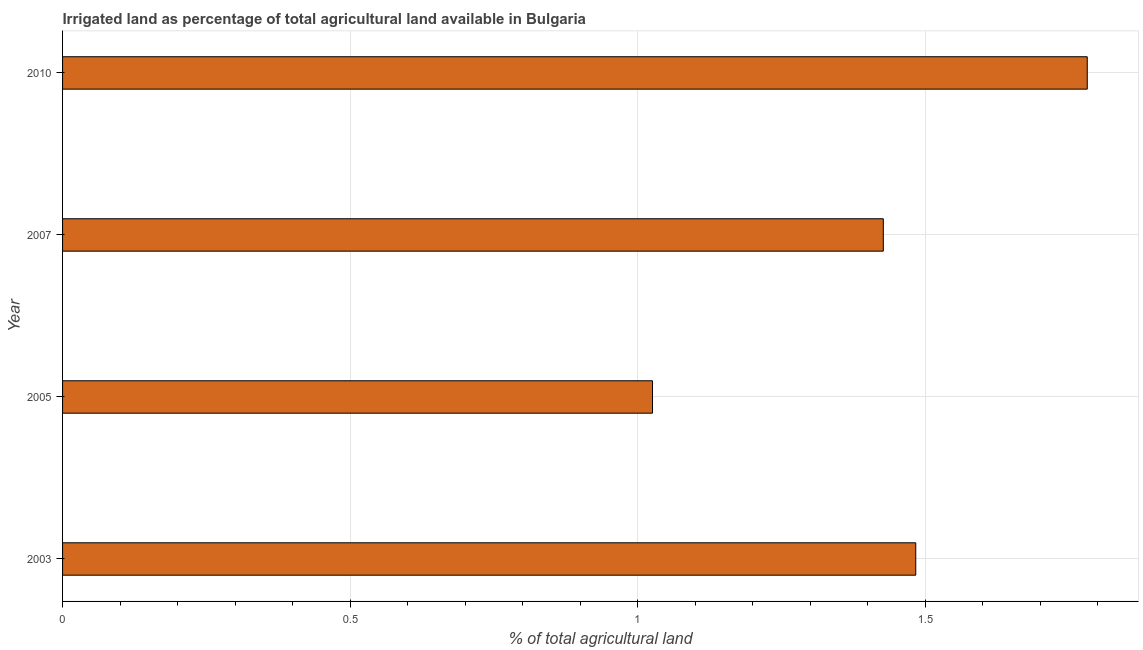Does the graph contain grids?
Your response must be concise. Yes. What is the title of the graph?
Provide a short and direct response. Irrigated land as percentage of total agricultural land available in Bulgaria. What is the label or title of the X-axis?
Offer a very short reply. % of total agricultural land. What is the label or title of the Y-axis?
Ensure brevity in your answer.  Year. What is the percentage of agricultural irrigated land in 2007?
Offer a very short reply. 1.43. Across all years, what is the maximum percentage of agricultural irrigated land?
Ensure brevity in your answer.  1.78. Across all years, what is the minimum percentage of agricultural irrigated land?
Provide a short and direct response. 1.03. In which year was the percentage of agricultural irrigated land maximum?
Make the answer very short. 2010. What is the sum of the percentage of agricultural irrigated land?
Provide a short and direct response. 5.72. What is the difference between the percentage of agricultural irrigated land in 2005 and 2007?
Ensure brevity in your answer.  -0.4. What is the average percentage of agricultural irrigated land per year?
Your response must be concise. 1.43. What is the median percentage of agricultural irrigated land?
Give a very brief answer. 1.46. In how many years, is the percentage of agricultural irrigated land greater than 1.1 %?
Keep it short and to the point. 3. Is the difference between the percentage of agricultural irrigated land in 2003 and 2007 greater than the difference between any two years?
Offer a very short reply. No. What is the difference between the highest and the second highest percentage of agricultural irrigated land?
Keep it short and to the point. 0.3. What is the difference between the highest and the lowest percentage of agricultural irrigated land?
Provide a succinct answer. 0.76. In how many years, is the percentage of agricultural irrigated land greater than the average percentage of agricultural irrigated land taken over all years?
Ensure brevity in your answer.  2. Are all the bars in the graph horizontal?
Your answer should be very brief. Yes. How many years are there in the graph?
Give a very brief answer. 4. What is the % of total agricultural land of 2003?
Your response must be concise. 1.48. What is the % of total agricultural land of 2005?
Make the answer very short. 1.03. What is the % of total agricultural land of 2007?
Make the answer very short. 1.43. What is the % of total agricultural land of 2010?
Give a very brief answer. 1.78. What is the difference between the % of total agricultural land in 2003 and 2005?
Your answer should be compact. 0.46. What is the difference between the % of total agricultural land in 2003 and 2007?
Make the answer very short. 0.06. What is the difference between the % of total agricultural land in 2003 and 2010?
Your answer should be very brief. -0.3. What is the difference between the % of total agricultural land in 2005 and 2007?
Your answer should be very brief. -0.4. What is the difference between the % of total agricultural land in 2005 and 2010?
Your response must be concise. -0.76. What is the difference between the % of total agricultural land in 2007 and 2010?
Provide a succinct answer. -0.35. What is the ratio of the % of total agricultural land in 2003 to that in 2005?
Offer a very short reply. 1.45. What is the ratio of the % of total agricultural land in 2003 to that in 2007?
Offer a very short reply. 1.04. What is the ratio of the % of total agricultural land in 2003 to that in 2010?
Your answer should be very brief. 0.83. What is the ratio of the % of total agricultural land in 2005 to that in 2007?
Offer a very short reply. 0.72. What is the ratio of the % of total agricultural land in 2005 to that in 2010?
Ensure brevity in your answer.  0.58. What is the ratio of the % of total agricultural land in 2007 to that in 2010?
Provide a short and direct response. 0.8. 